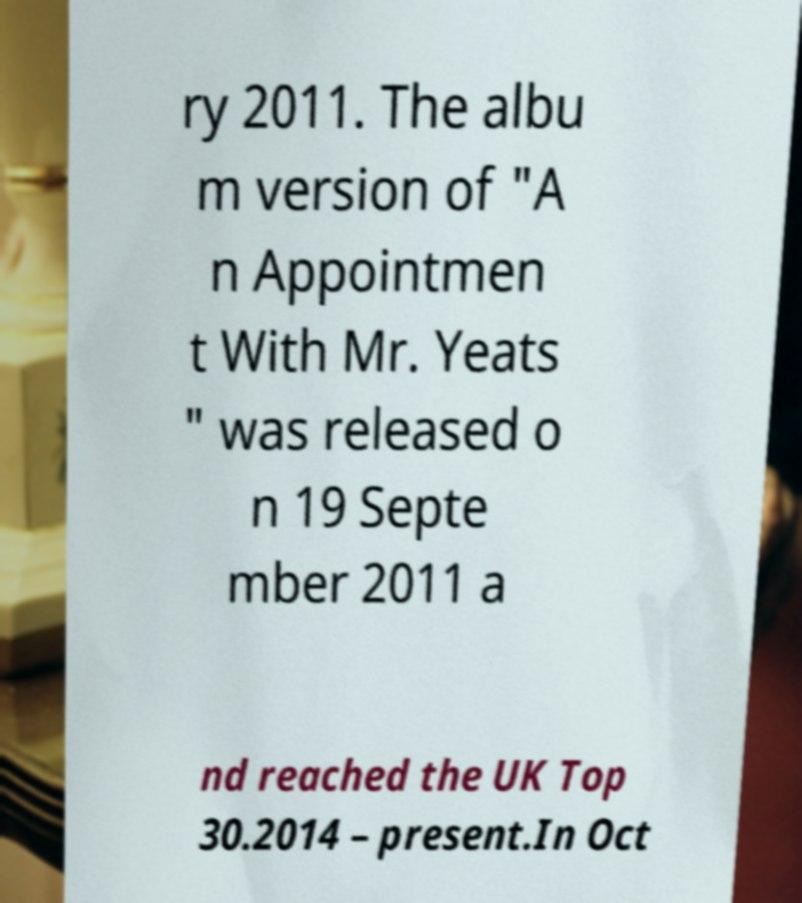I need the written content from this picture converted into text. Can you do that? ry 2011. The albu m version of "A n Appointmen t With Mr. Yeats " was released o n 19 Septe mber 2011 a nd reached the UK Top 30.2014 – present.In Oct 